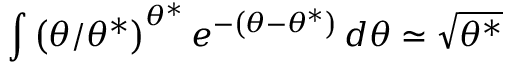<formula> <loc_0><loc_0><loc_500><loc_500>\int \left ( \theta / \theta ^ { * } \right ) ^ { \theta ^ { * } } e ^ { - \left ( \theta - \theta ^ { * } \right ) } \, d \theta \simeq \sqrt { \theta ^ { * } }</formula> 